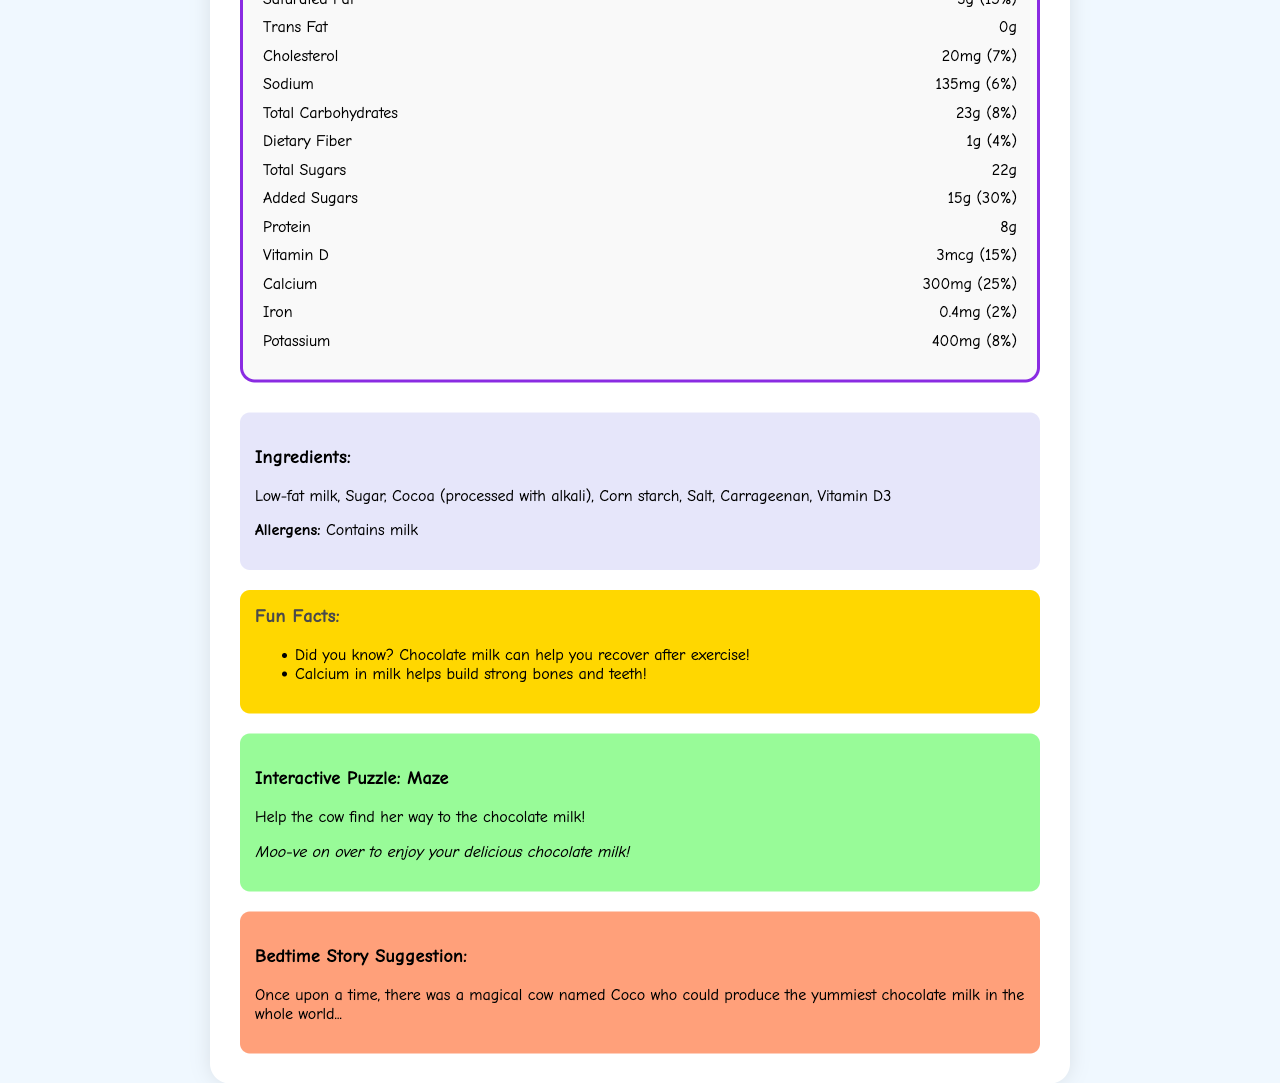what is the serving size for Moo-velous Chocolate Milk? The serving size is listed as "1 cup (240ml)" in the Nutrition Facts section.
Answer: 1 cup (240ml) how many calories are in one serving? The document states that each serving contains 150 calories.
Answer: 150 calories what is the amount of protein per serving? The Nutrition Facts section specifies that there are 8 grams of protein per serving.
Answer: 8g how much saturated fat does one serving contain? Saturated fat content per serving is listed as 3 grams.
Answer: 3g how many servings are there in one container? The document states there are 4 servings per container.
Answer: 4 what percentage of the daily value for calcium does one serving provide? Each serving provides 25% of the daily value for calcium.
Answer: 25% which ingredient is listed first? The first ingredient listed in the ingredient section is "Low-fat milk".
Answer: Low-fat milk what is the main fun fact about chocolate milk listed in the document? One of the fun facts states that chocolate milk can help with recovery after exercise.
Answer: Did you know? Chocolate milk can help you recover after exercise! what percentage of the daily value for added sugars does one serving have? Each serving contains 30% of the daily value for added sugars.
Answer: 30% what task does the interactive puzzle involve? The task for the puzzle is to help the cow find her way to the chocolate milk.
Answer: Help the cow find her way to the chocolate milk! what allergens are present in Moo-velous Chocolate Milk? The allergens section specifies that it contains milk.
Answer: Contains milk which ingredient is NOT listed in Moo-velous Chocolate Milk? A. Cocoa B. Sugar C. Almond Milk The listed ingredients include Cocoa and Sugar, but not Almond Milk.
Answer: C. Almond Milk which is higher in quantity in a serving of Moo-velous Chocolate Milk? A. Protein B. Dietary Fiber C. Total Sugars Total Sugars are 22g, Protein is 8g, and Dietary Fiber is 1g.
Answer: C. Total Sugars is there any trans fat in this chocolate milk? The document states that the amount of trans fat is 0g.
Answer: No can this document tell you how chocolate milk is made? The document does not provide specific instructions or information on how chocolate milk is made.
Answer: Not enough information summarize the Moo-velous Chocolate Milk document This summary captures the essential elements and organization of the document, outlining its main sections and content.
Answer: The document provides nutrition facts, ingredients, allergens, and fun facts about Moo-velous Chocolate Milk. It includes detailed information about the serving size, calories, macronutrients, and daily values for vitamins and minerals. It also features an interactive puzzle and a bedtime story suggestion about a magical cow named Coco who makes the yummiest chocolate milk. 